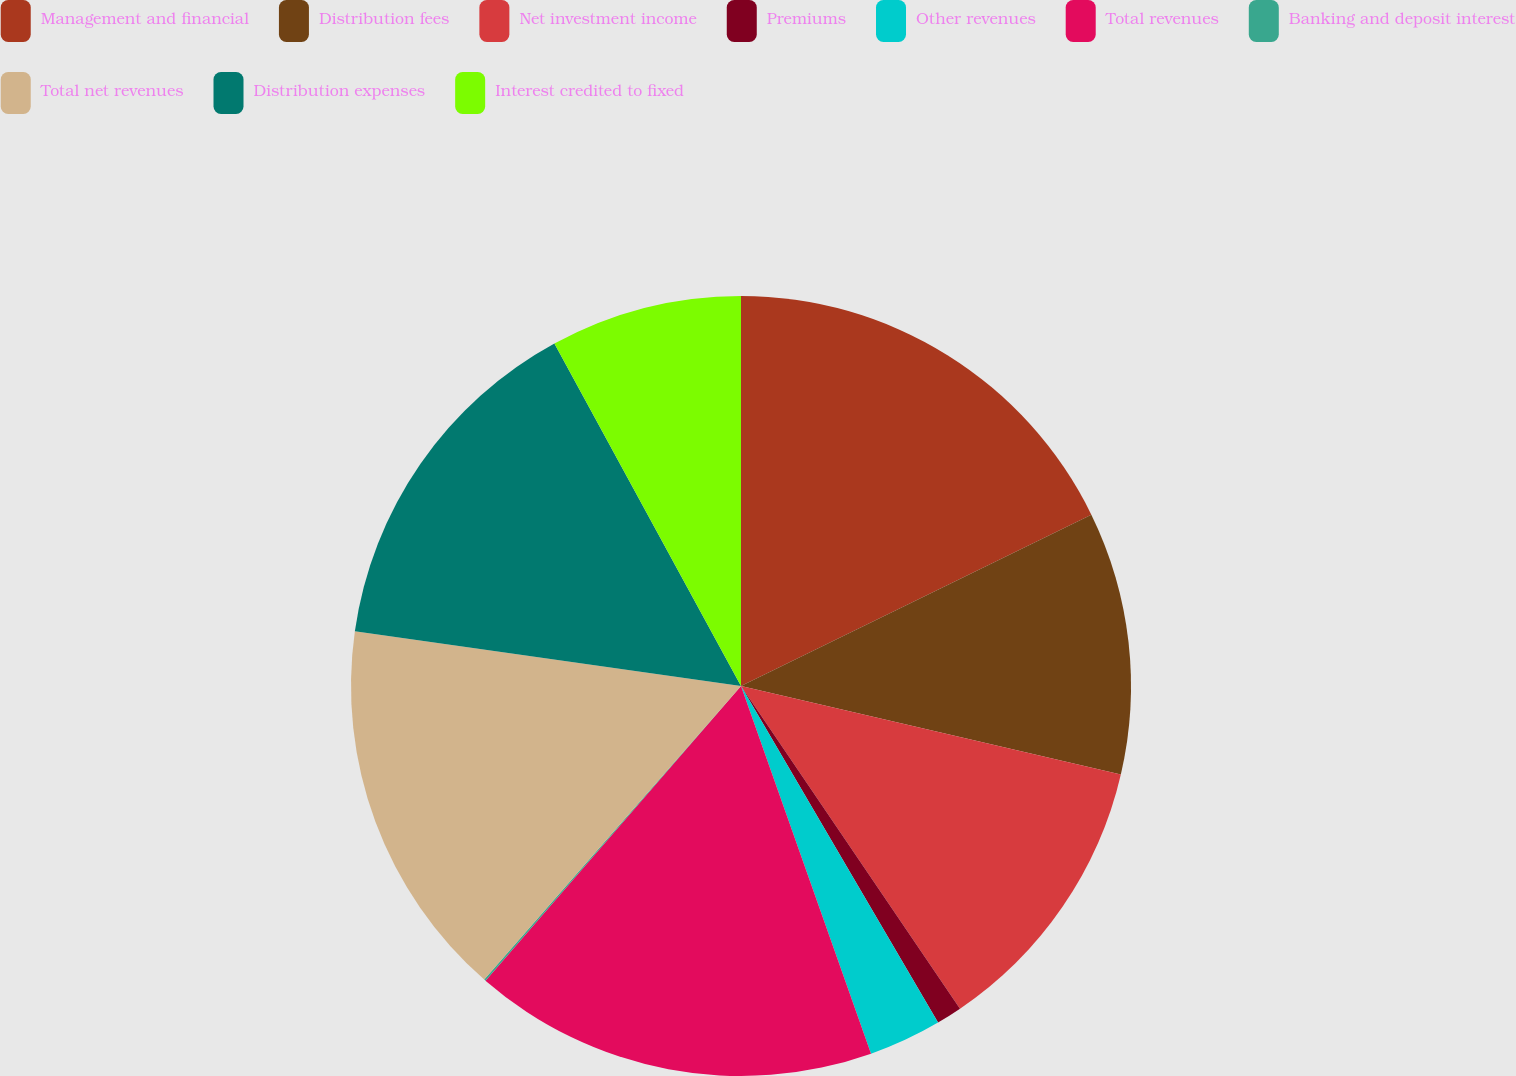Convert chart to OTSL. <chart><loc_0><loc_0><loc_500><loc_500><pie_chart><fcel>Management and financial<fcel>Distribution fees<fcel>Net investment income<fcel>Premiums<fcel>Other revenues<fcel>Total revenues<fcel>Banking and deposit interest<fcel>Total net revenues<fcel>Distribution expenses<fcel>Interest credited to fixed<nl><fcel>17.76%<fcel>10.88%<fcel>11.87%<fcel>1.06%<fcel>3.02%<fcel>16.78%<fcel>0.07%<fcel>15.8%<fcel>14.82%<fcel>7.94%<nl></chart> 